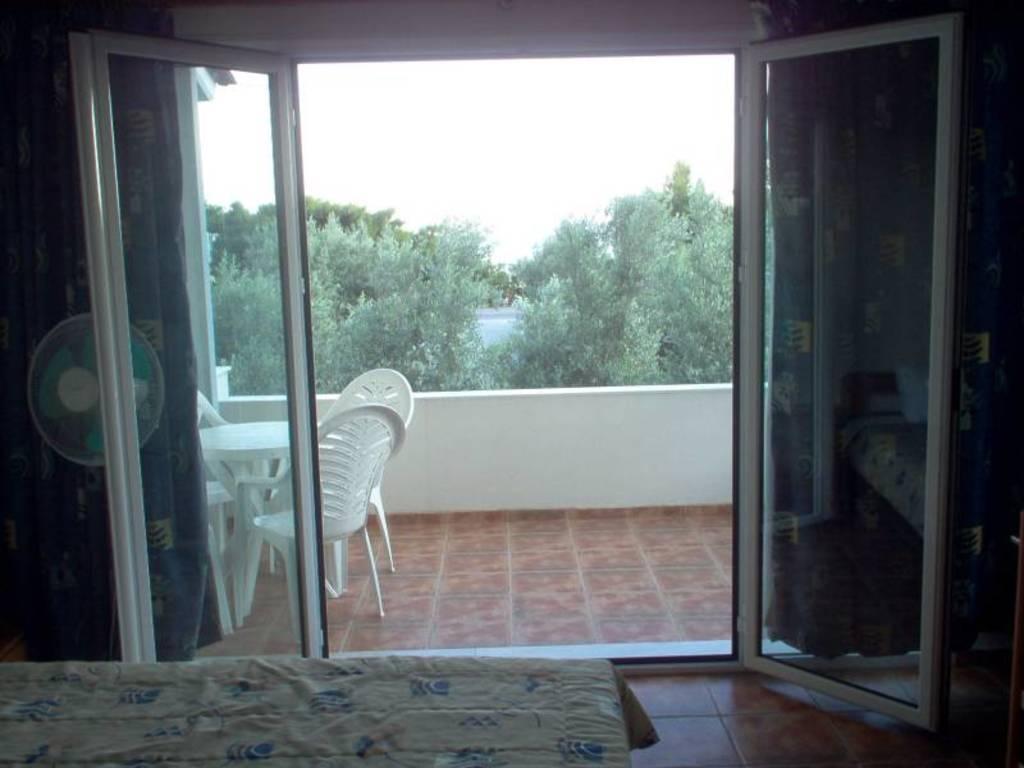Can you describe this image briefly? This image consists of a door. And we can see a balcony in which there are chairs and a table. In the background, there are trees. At the top, there is sky. At the bottom, there is a bed. On the right, we can see a floor. 